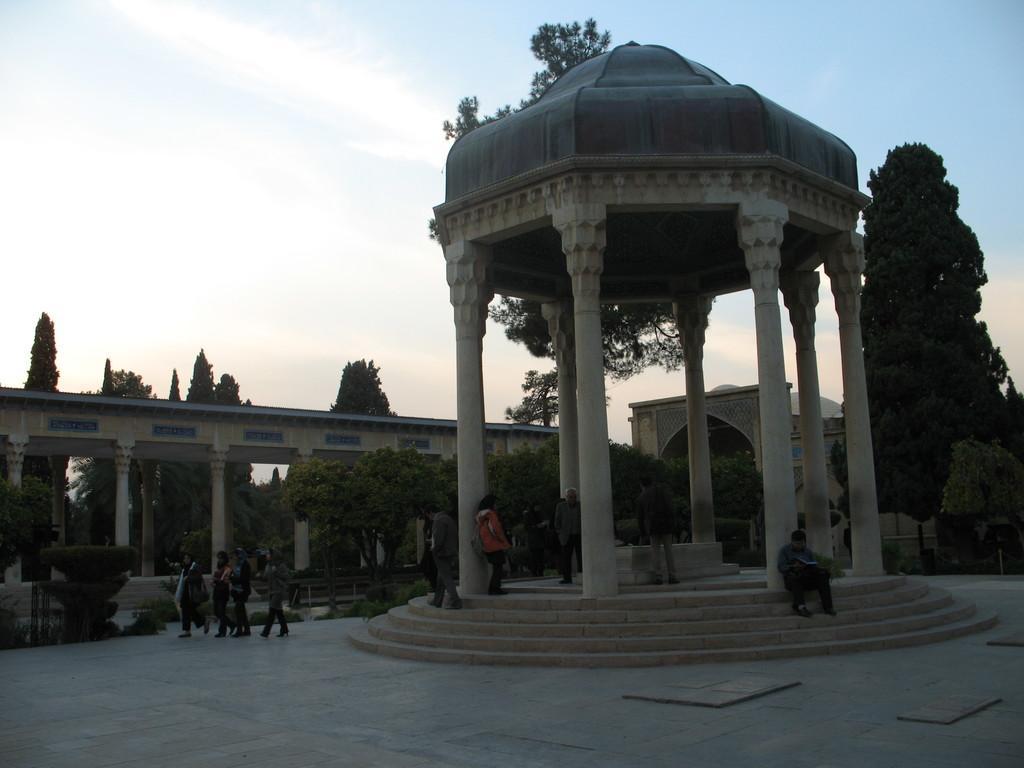Can you describe this image briefly? This picture describes about group of people, in the background we can see few trees, clouds and a building. 